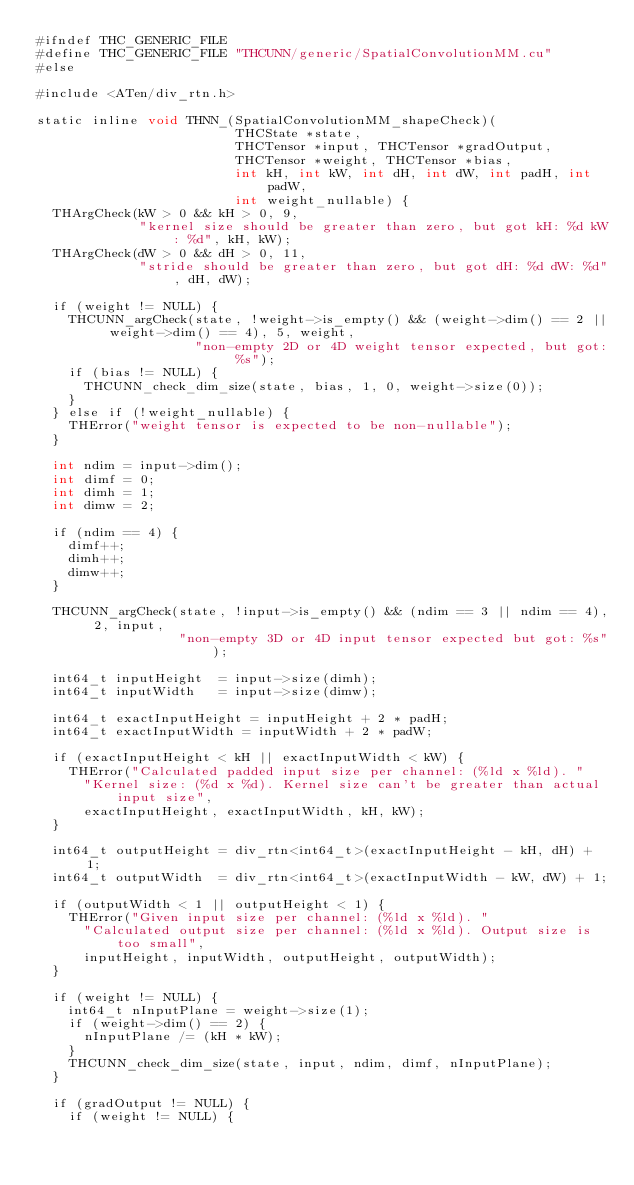Convert code to text. <code><loc_0><loc_0><loc_500><loc_500><_Cuda_>#ifndef THC_GENERIC_FILE
#define THC_GENERIC_FILE "THCUNN/generic/SpatialConvolutionMM.cu"
#else

#include <ATen/div_rtn.h>

static inline void THNN_(SpatialConvolutionMM_shapeCheck)(
                         THCState *state,
                         THCTensor *input, THCTensor *gradOutput,
                         THCTensor *weight, THCTensor *bias,
                         int kH, int kW, int dH, int dW, int padH, int padW,
                         int weight_nullable) {
  THArgCheck(kW > 0 && kH > 0, 9,
             "kernel size should be greater than zero, but got kH: %d kW: %d", kH, kW);
  THArgCheck(dW > 0 && dH > 0, 11,
             "stride should be greater than zero, but got dH: %d dW: %d", dH, dW);

  if (weight != NULL) {
    THCUNN_argCheck(state, !weight->is_empty() && (weight->dim() == 2 || weight->dim() == 4), 5, weight,
                    "non-empty 2D or 4D weight tensor expected, but got: %s");
    if (bias != NULL) {
      THCUNN_check_dim_size(state, bias, 1, 0, weight->size(0));
    }
  } else if (!weight_nullable) {
    THError("weight tensor is expected to be non-nullable");
  }

  int ndim = input->dim();
  int dimf = 0;
  int dimh = 1;
  int dimw = 2;

  if (ndim == 4) {
    dimf++;
    dimh++;
    dimw++;
  }

  THCUNN_argCheck(state, !input->is_empty() && (ndim == 3 || ndim == 4), 2, input,
                  "non-empty 3D or 4D input tensor expected but got: %s");

  int64_t inputHeight  = input->size(dimh);
  int64_t inputWidth   = input->size(dimw);

  int64_t exactInputHeight = inputHeight + 2 * padH;
  int64_t exactInputWidth = inputWidth + 2 * padW;

  if (exactInputHeight < kH || exactInputWidth < kW) {
    THError("Calculated padded input size per channel: (%ld x %ld). "
      "Kernel size: (%d x %d). Kernel size can't be greater than actual input size",
      exactInputHeight, exactInputWidth, kH, kW);
  }

  int64_t outputHeight = div_rtn<int64_t>(exactInputHeight - kH, dH) + 1;
  int64_t outputWidth  = div_rtn<int64_t>(exactInputWidth - kW, dW) + 1;

  if (outputWidth < 1 || outputHeight < 1) {
    THError("Given input size per channel: (%ld x %ld). "
      "Calculated output size per channel: (%ld x %ld). Output size is too small",
      inputHeight, inputWidth, outputHeight, outputWidth);
  }

  if (weight != NULL) {
    int64_t nInputPlane = weight->size(1);
    if (weight->dim() == 2) {
      nInputPlane /= (kH * kW);
    }
    THCUNN_check_dim_size(state, input, ndim, dimf, nInputPlane);
  }

  if (gradOutput != NULL) {
    if (weight != NULL) {</code> 